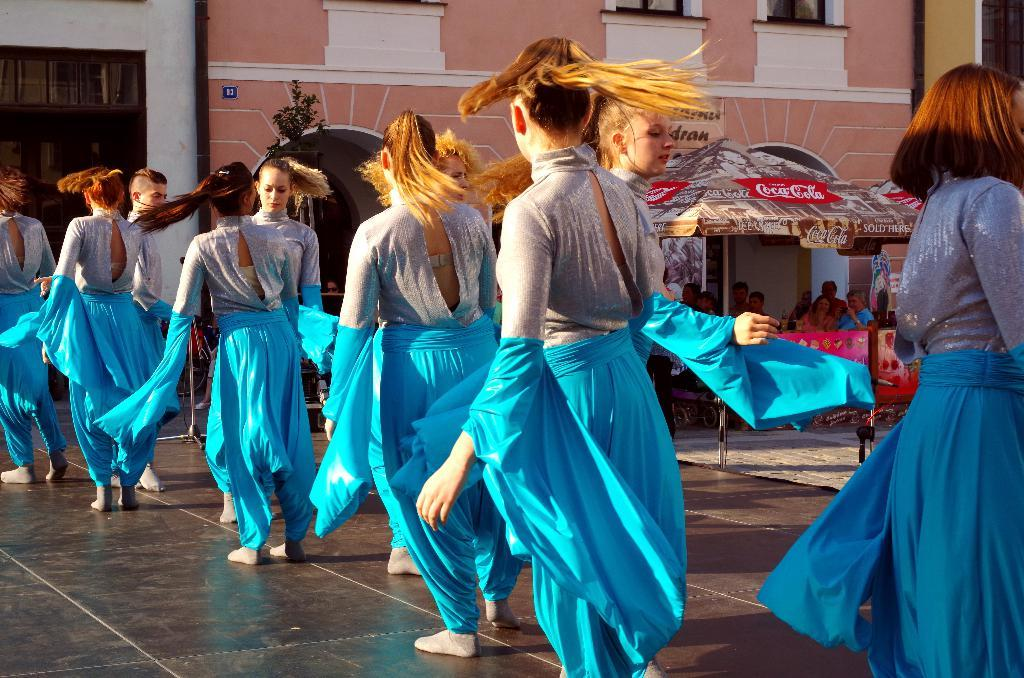How many people are visible in the image? There is a group of people standing in the image. Where are the people standing? The people are standing on the floor. What can be seen in the background of the image? There is an umbrella, people, posters, a tree, and buildings with windows in the background of the image. What type of crack is visible on the floor in the image? There is no crack visible on the floor in the image. What time of day is it in the image, given the presence of pigs and morning? There are no pigs or references to morning in the image, so it is not possible to determine the time of day. 